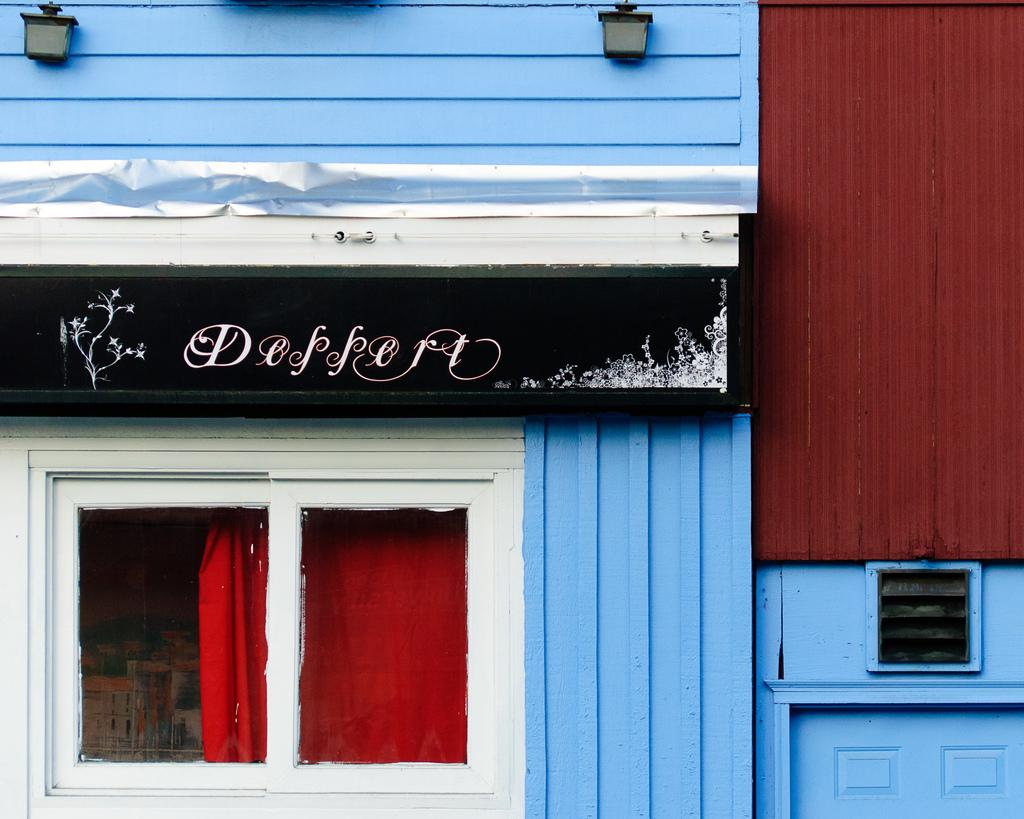What type of structure can be seen in the image? There is a wall in the image. What feature of the wall is visible in the image? There are windows in the image. Are there any window treatments visible in the image? Yes, there are curtains in the image. What is written or displayed on a board in the image? There is written text on a board in the image. What objects can be seen near the board in the image? There are visible in the image. How does the kitten manage to crush the sleet in the image? There is no kitten or sleet present in the image. 